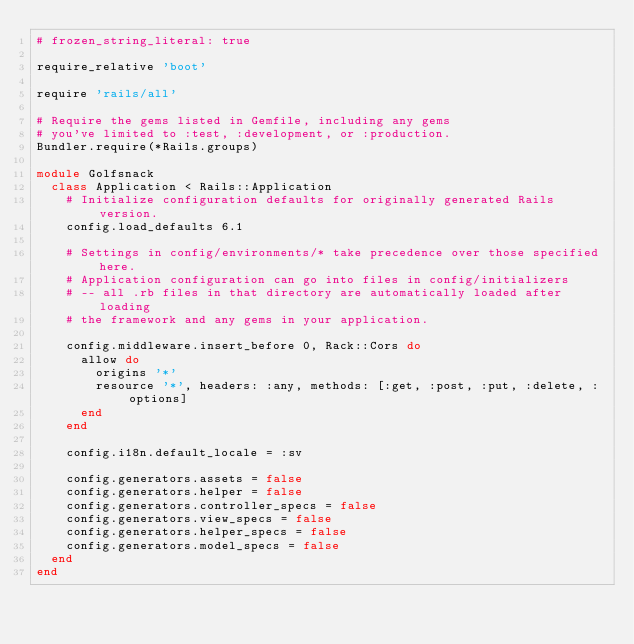<code> <loc_0><loc_0><loc_500><loc_500><_Ruby_># frozen_string_literal: true

require_relative 'boot'

require 'rails/all'

# Require the gems listed in Gemfile, including any gems
# you've limited to :test, :development, or :production.
Bundler.require(*Rails.groups)

module Golfsnack
  class Application < Rails::Application
    # Initialize configuration defaults for originally generated Rails version.
    config.load_defaults 6.1

    # Settings in config/environments/* take precedence over those specified here.
    # Application configuration can go into files in config/initializers
    # -- all .rb files in that directory are automatically loaded after loading
    # the framework and any gems in your application.

    config.middleware.insert_before 0, Rack::Cors do
      allow do
        origins '*'
        resource '*', headers: :any, methods: [:get, :post, :put, :delete, :options]
      end
    end

    config.i18n.default_locale = :sv

    config.generators.assets = false
    config.generators.helper = false
    config.generators.controller_specs = false
    config.generators.view_specs = false
    config.generators.helper_specs = false
    config.generators.model_specs = false
  end
end
</code> 